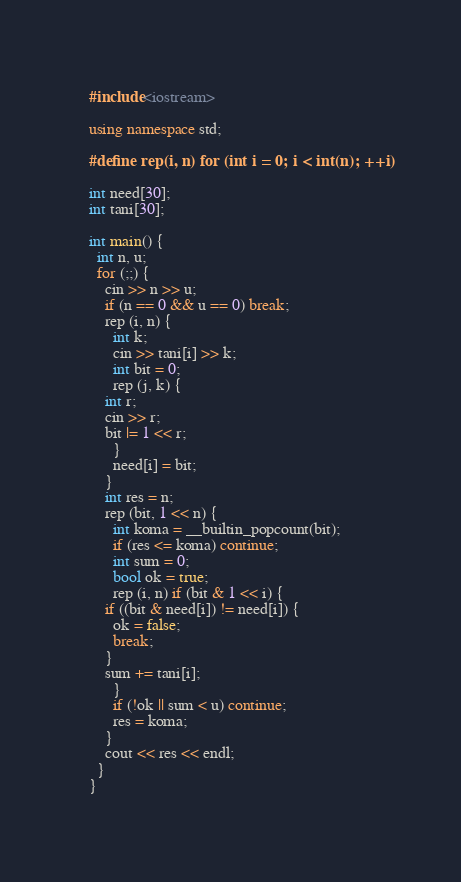<code> <loc_0><loc_0><loc_500><loc_500><_C++_>#include<iostream>

using namespace std;

#define rep(i, n) for (int i = 0; i < int(n); ++i)

int need[30];
int tani[30];

int main() {
  int n, u;
  for (;;) {
    cin >> n >> u;
    if (n == 0 && u == 0) break;
    rep (i, n) {
      int k;
      cin >> tani[i] >> k;
      int bit = 0;
      rep (j, k) {
	int r;
	cin >> r;
	bit |= 1 << r;
      }
      need[i] = bit;
    }
    int res = n;
    rep (bit, 1 << n) {
      int koma = __builtin_popcount(bit);
      if (res <= koma) continue;
      int sum = 0;
      bool ok = true;
      rep (i, n) if (bit & 1 << i) {
	if ((bit & need[i]) != need[i]) {
	  ok = false;
	  break;
	}
	sum += tani[i];
      }
      if (!ok || sum < u) continue;
      res = koma;
    }
    cout << res << endl;
  }
}</code> 